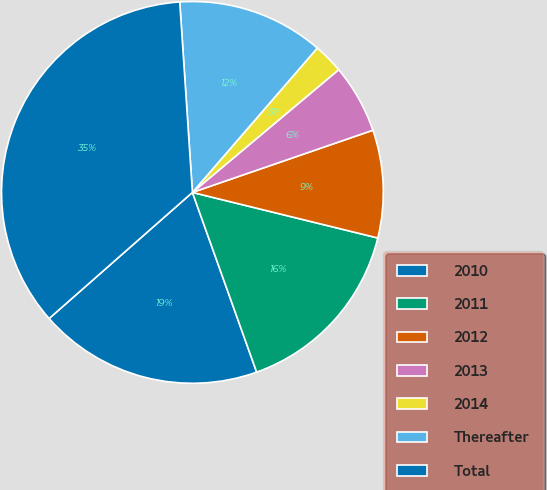Convert chart. <chart><loc_0><loc_0><loc_500><loc_500><pie_chart><fcel>2010<fcel>2011<fcel>2012<fcel>2013<fcel>2014<fcel>Thereafter<fcel>Total<nl><fcel>18.98%<fcel>15.7%<fcel>9.12%<fcel>5.83%<fcel>2.54%<fcel>12.41%<fcel>35.43%<nl></chart> 